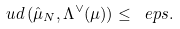<formula> <loc_0><loc_0><loc_500><loc_500>\ u d \, ( \hat { \mu } _ { N } , \Lambda ^ { \vee } ( \mu ) ) \leq \ e p s .</formula> 